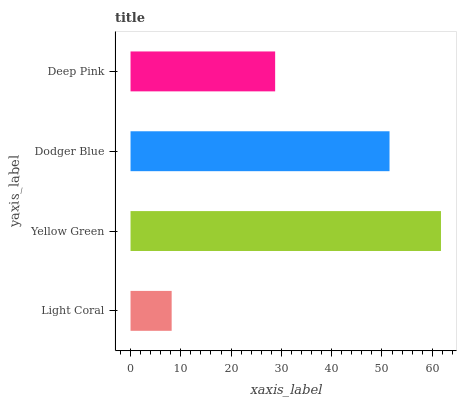Is Light Coral the minimum?
Answer yes or no. Yes. Is Yellow Green the maximum?
Answer yes or no. Yes. Is Dodger Blue the minimum?
Answer yes or no. No. Is Dodger Blue the maximum?
Answer yes or no. No. Is Yellow Green greater than Dodger Blue?
Answer yes or no. Yes. Is Dodger Blue less than Yellow Green?
Answer yes or no. Yes. Is Dodger Blue greater than Yellow Green?
Answer yes or no. No. Is Yellow Green less than Dodger Blue?
Answer yes or no. No. Is Dodger Blue the high median?
Answer yes or no. Yes. Is Deep Pink the low median?
Answer yes or no. Yes. Is Light Coral the high median?
Answer yes or no. No. Is Dodger Blue the low median?
Answer yes or no. No. 